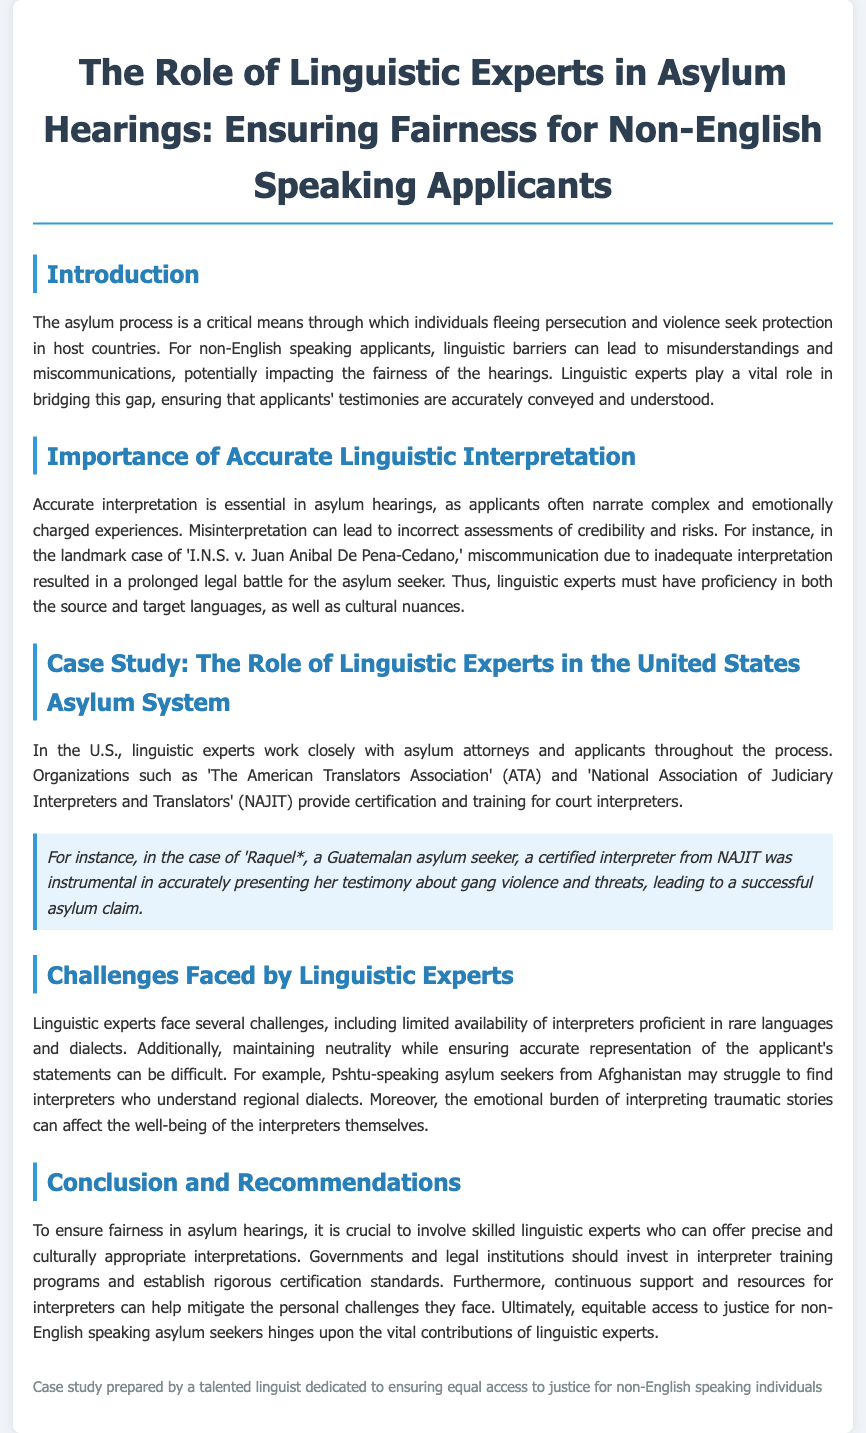What is the title of the case study? The title summarizing the focus on linguistic experts in asylum hearings is provided at the beginning of the document.
Answer: The Role of Linguistic Experts in Asylum Hearings: Ensuring Fairness for Non-English Speaking Applicants Who are the two organizations mentioned that provide certification for interpreters? The document lists two key organizations that contribute to interpreter certification and training, important for ensuring quality in asylum hearings.
Answer: The American Translators Association and National Association of Judiciary Interpreters and Translators What was the outcome for Raquel, the Guatemalan asylum seeker? The document highlights a successful asylum claim as a direct result of effective interpretation in Raquel's case, demonstrating the importance of linguistic experts.
Answer: Successful asylum claim Which language's dialects are specifically mentioned as facing challenges in interpretation? The document addresses the challenge of finding interpreters for specific language dialects, illustrating the difficulties faced in accurately representing asylum seekers' statements.
Answer: Pashtu What is one major challenge faced by linguistic experts? The document outlines various challenges that linguistic experts encounter, providing insight into the complexities of their role within the asylum process.
Answer: Limited availability of interpreters What recommendation is made regarding government action? The conclusion emphasizes actions that governments should take to improve the fairness of asylum hearings, highlighting the need for specific measures to support linguistic experts.
Answer: Invest in interpreter training programs 